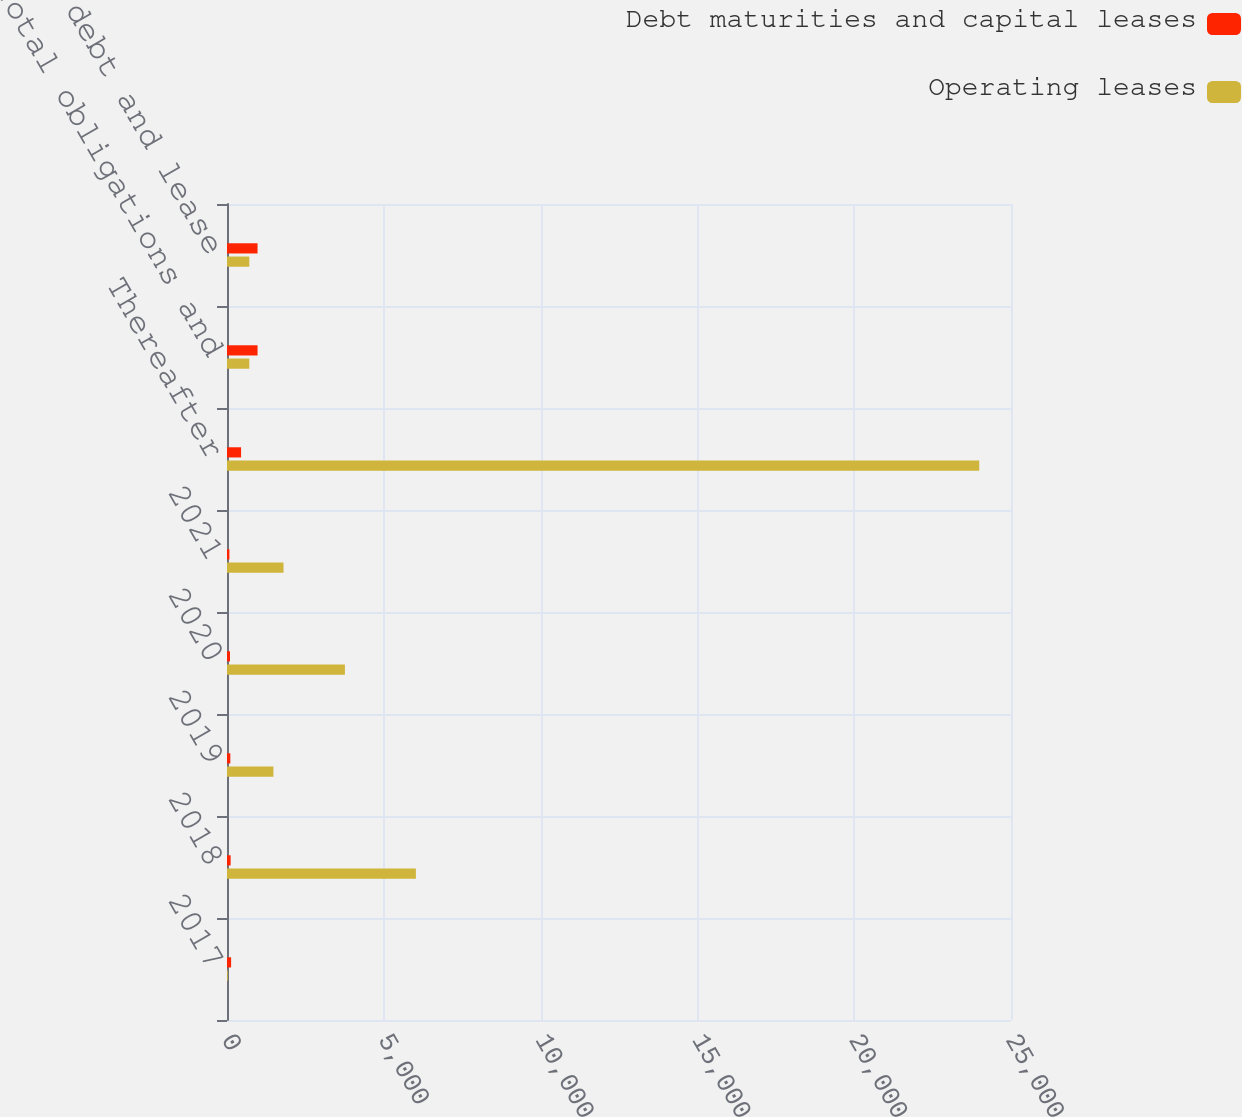<chart> <loc_0><loc_0><loc_500><loc_500><stacked_bar_chart><ecel><fcel>2017<fcel>2018<fcel>2019<fcel>2020<fcel>2021<fcel>Thereafter<fcel>Total obligations and<fcel>Total debt and lease<nl><fcel>Debt maturities and capital leases<fcel>131<fcel>116<fcel>106<fcel>95<fcel>77<fcel>449<fcel>974<fcel>974<nl><fcel>Operating leases<fcel>25<fcel>6023<fcel>1480<fcel>3760<fcel>1802<fcel>23987<fcel>711.5<fcel>711.5<nl></chart> 